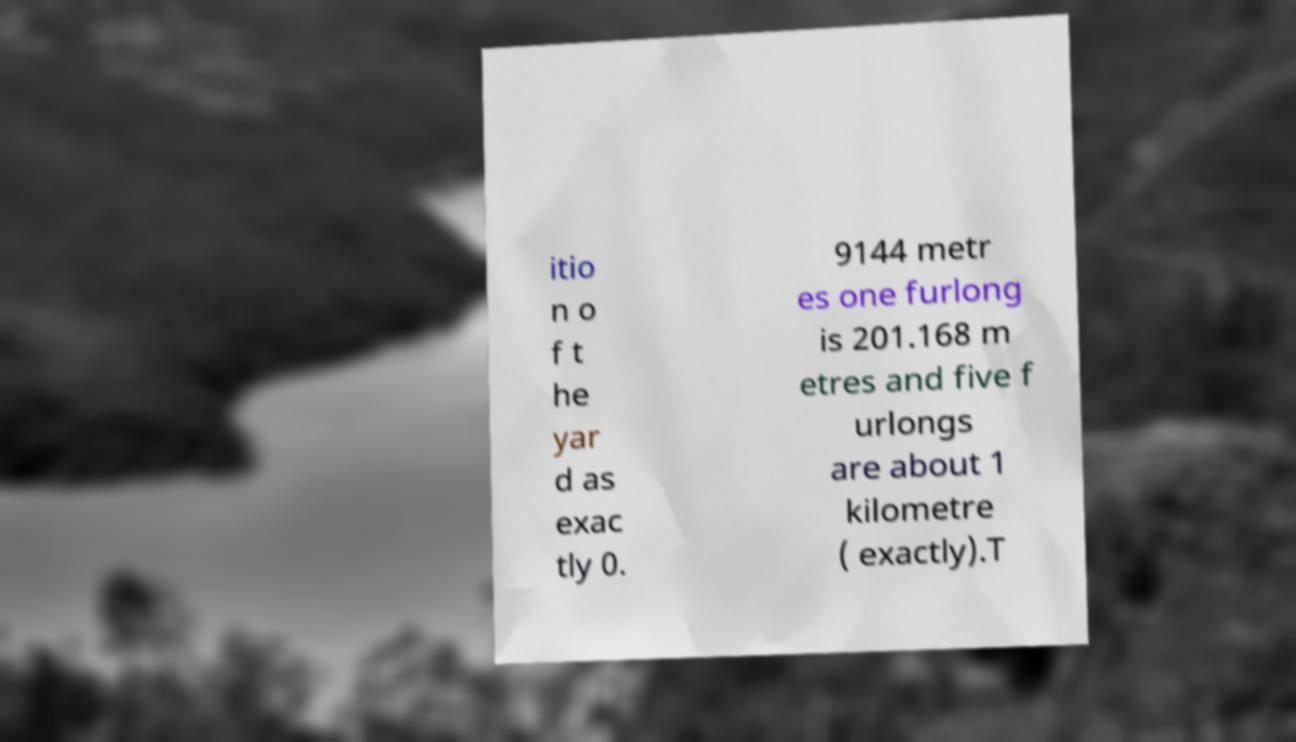I need the written content from this picture converted into text. Can you do that? itio n o f t he yar d as exac tly 0. 9144 metr es one furlong is 201.168 m etres and five f urlongs are about 1 kilometre ( exactly).T 